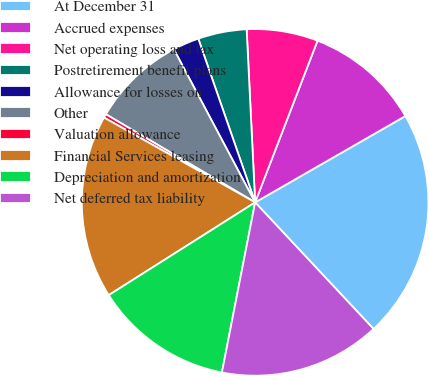<chart> <loc_0><loc_0><loc_500><loc_500><pie_chart><fcel>At December 31<fcel>Accrued expenses<fcel>Net operating loss and tax<fcel>Postretirement benefit plans<fcel>Allowance for losses on<fcel>Other<fcel>Valuation allowance<fcel>Financial Services leasing<fcel>Depreciation and amortization<fcel>Net deferred tax liability<nl><fcel>21.33%<fcel>10.84%<fcel>6.64%<fcel>4.54%<fcel>2.45%<fcel>8.74%<fcel>0.35%<fcel>17.13%<fcel>12.94%<fcel>15.04%<nl></chart> 